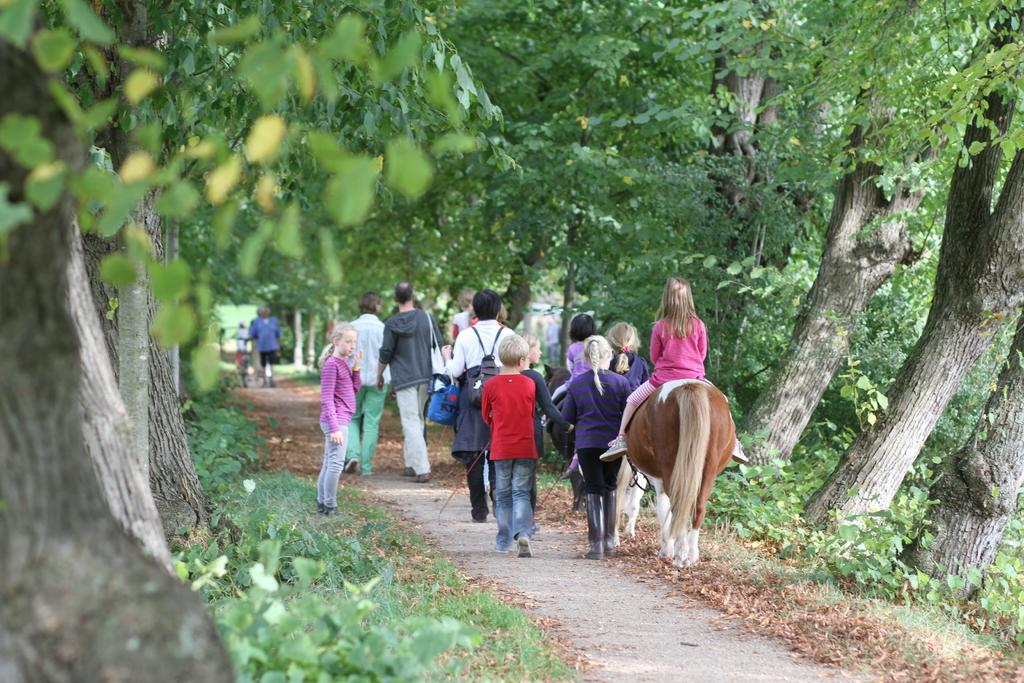How many people are in the image? There are people in the image, but the exact number is not specified. What are some of the people doing in the image? Some people are riding horses, and a kid is riding a bicycle. What type of vegetation can be seen in the image? There are trees, plants, and leaves on the ground visible in the image. What is the ground made of in the image? The ground is made of grass, which is visible in the image. What type of flower is being rubbed by the person in the image? There is no flower present in the image, so it cannot be rubbed by anyone. How does the person in the image control the horse? The facts do not mention how the person controls the horse, so we cannot answer this question definitively. 